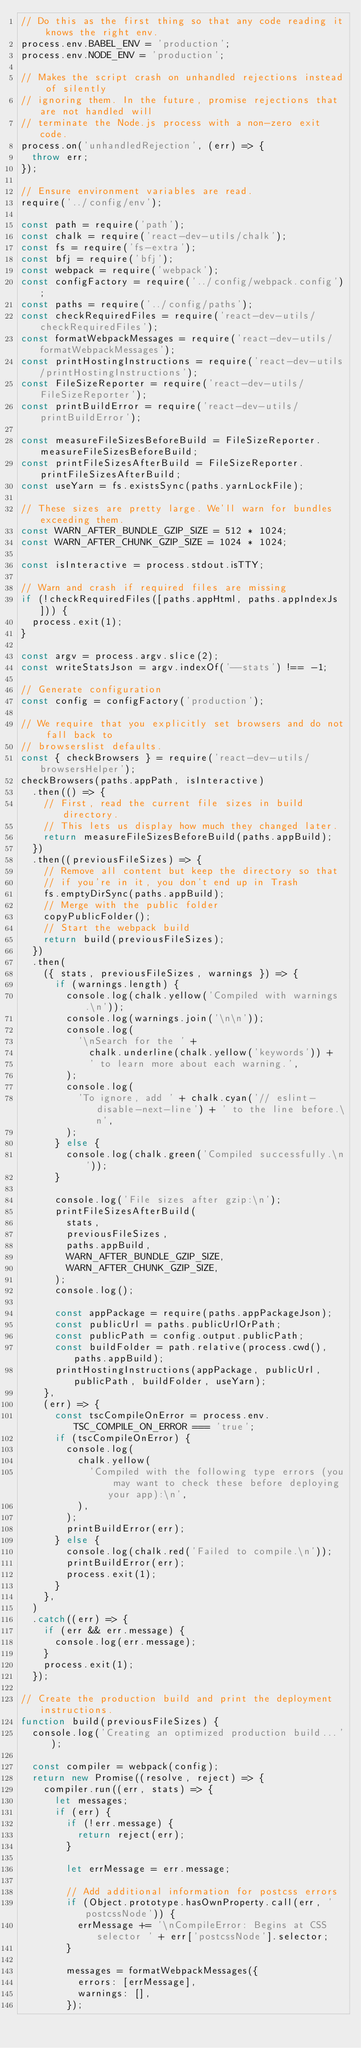Convert code to text. <code><loc_0><loc_0><loc_500><loc_500><_JavaScript_>// Do this as the first thing so that any code reading it knows the right env.
process.env.BABEL_ENV = 'production';
process.env.NODE_ENV = 'production';

// Makes the script crash on unhandled rejections instead of silently
// ignoring them. In the future, promise rejections that are not handled will
// terminate the Node.js process with a non-zero exit code.
process.on('unhandledRejection', (err) => {
  throw err;
});

// Ensure environment variables are read.
require('../config/env');

const path = require('path');
const chalk = require('react-dev-utils/chalk');
const fs = require('fs-extra');
const bfj = require('bfj');
const webpack = require('webpack');
const configFactory = require('../config/webpack.config');
const paths = require('../config/paths');
const checkRequiredFiles = require('react-dev-utils/checkRequiredFiles');
const formatWebpackMessages = require('react-dev-utils/formatWebpackMessages');
const printHostingInstructions = require('react-dev-utils/printHostingInstructions');
const FileSizeReporter = require('react-dev-utils/FileSizeReporter');
const printBuildError = require('react-dev-utils/printBuildError');

const measureFileSizesBeforeBuild = FileSizeReporter.measureFileSizesBeforeBuild;
const printFileSizesAfterBuild = FileSizeReporter.printFileSizesAfterBuild;
const useYarn = fs.existsSync(paths.yarnLockFile);

// These sizes are pretty large. We'll warn for bundles exceeding them.
const WARN_AFTER_BUNDLE_GZIP_SIZE = 512 * 1024;
const WARN_AFTER_CHUNK_GZIP_SIZE = 1024 * 1024;

const isInteractive = process.stdout.isTTY;

// Warn and crash if required files are missing
if (!checkRequiredFiles([paths.appHtml, paths.appIndexJs])) {
  process.exit(1);
}

const argv = process.argv.slice(2);
const writeStatsJson = argv.indexOf('--stats') !== -1;

// Generate configuration
const config = configFactory('production');

// We require that you explicitly set browsers and do not fall back to
// browserslist defaults.
const { checkBrowsers } = require('react-dev-utils/browsersHelper');
checkBrowsers(paths.appPath, isInteractive)
  .then(() => {
    // First, read the current file sizes in build directory.
    // This lets us display how much they changed later.
    return measureFileSizesBeforeBuild(paths.appBuild);
  })
  .then((previousFileSizes) => {
    // Remove all content but keep the directory so that
    // if you're in it, you don't end up in Trash
    fs.emptyDirSync(paths.appBuild);
    // Merge with the public folder
    copyPublicFolder();
    // Start the webpack build
    return build(previousFileSizes);
  })
  .then(
    ({ stats, previousFileSizes, warnings }) => {
      if (warnings.length) {
        console.log(chalk.yellow('Compiled with warnings.\n'));
        console.log(warnings.join('\n\n'));
        console.log(
          '\nSearch for the ' +
            chalk.underline(chalk.yellow('keywords')) +
            ' to learn more about each warning.',
        );
        console.log(
          'To ignore, add ' + chalk.cyan('// eslint-disable-next-line') + ' to the line before.\n',
        );
      } else {
        console.log(chalk.green('Compiled successfully.\n'));
      }

      console.log('File sizes after gzip:\n');
      printFileSizesAfterBuild(
        stats,
        previousFileSizes,
        paths.appBuild,
        WARN_AFTER_BUNDLE_GZIP_SIZE,
        WARN_AFTER_CHUNK_GZIP_SIZE,
      );
      console.log();

      const appPackage = require(paths.appPackageJson);
      const publicUrl = paths.publicUrlOrPath;
      const publicPath = config.output.publicPath;
      const buildFolder = path.relative(process.cwd(), paths.appBuild);
      printHostingInstructions(appPackage, publicUrl, publicPath, buildFolder, useYarn);
    },
    (err) => {
      const tscCompileOnError = process.env.TSC_COMPILE_ON_ERROR === 'true';
      if (tscCompileOnError) {
        console.log(
          chalk.yellow(
            'Compiled with the following type errors (you may want to check these before deploying your app):\n',
          ),
        );
        printBuildError(err);
      } else {
        console.log(chalk.red('Failed to compile.\n'));
        printBuildError(err);
        process.exit(1);
      }
    },
  )
  .catch((err) => {
    if (err && err.message) {
      console.log(err.message);
    }
    process.exit(1);
  });

// Create the production build and print the deployment instructions.
function build(previousFileSizes) {
  console.log('Creating an optimized production build...');

  const compiler = webpack(config);
  return new Promise((resolve, reject) => {
    compiler.run((err, stats) => {
      let messages;
      if (err) {
        if (!err.message) {
          return reject(err);
        }

        let errMessage = err.message;

        // Add additional information for postcss errors
        if (Object.prototype.hasOwnProperty.call(err, 'postcssNode')) {
          errMessage += '\nCompileError: Begins at CSS selector ' + err['postcssNode'].selector;
        }

        messages = formatWebpackMessages({
          errors: [errMessage],
          warnings: [],
        });</code> 